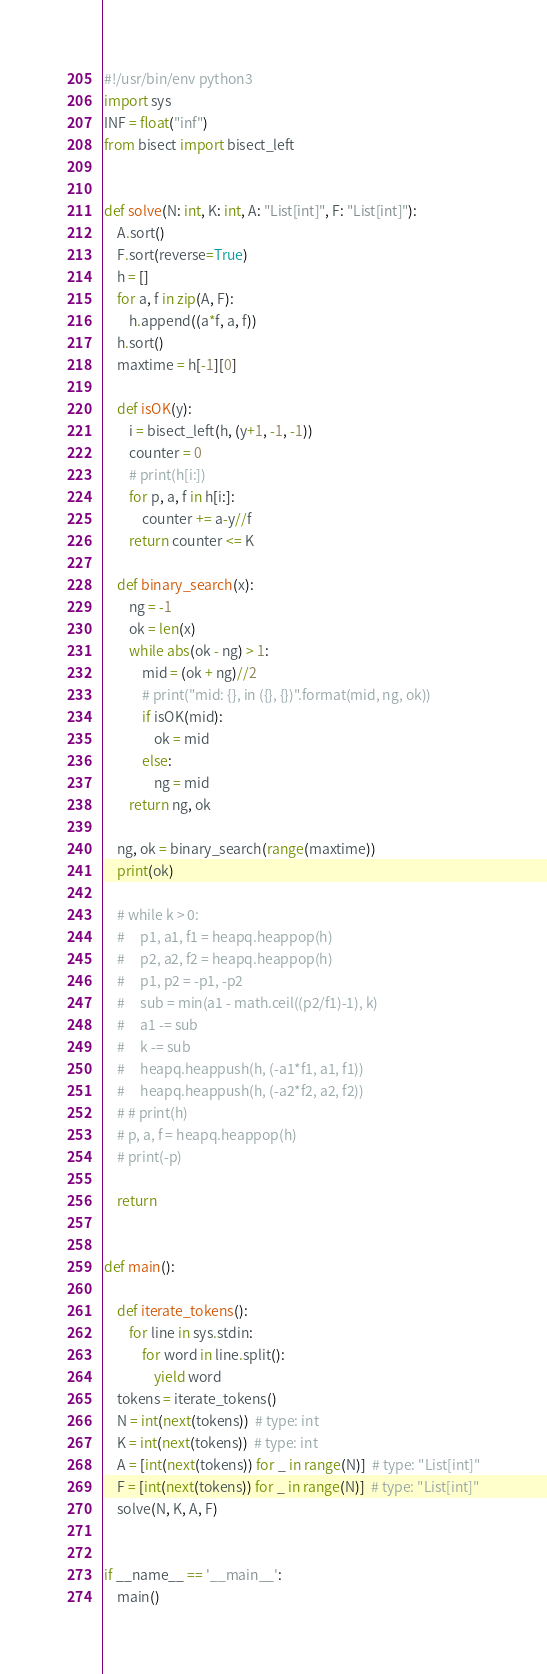<code> <loc_0><loc_0><loc_500><loc_500><_Python_>#!/usr/bin/env python3
import sys
INF = float("inf")
from bisect import bisect_left


def solve(N: int, K: int, A: "List[int]", F: "List[int]"):
    A.sort()
    F.sort(reverse=True)
    h = []
    for a, f in zip(A, F):
        h.append((a*f, a, f))
    h.sort()
    maxtime = h[-1][0]

    def isOK(y):
        i = bisect_left(h, (y+1, -1, -1))
        counter = 0
        # print(h[i:])
        for p, a, f in h[i:]:
            counter += a-y//f
        return counter <= K

    def binary_search(x):
        ng = -1
        ok = len(x)
        while abs(ok - ng) > 1:
            mid = (ok + ng)//2
            # print("mid: {}, in ({}, {})".format(mid, ng, ok))
            if isOK(mid):
                ok = mid
            else:
                ng = mid
        return ng, ok

    ng, ok = binary_search(range(maxtime))
    print(ok)

    # while k > 0:
    #     p1, a1, f1 = heapq.heappop(h)
    #     p2, a2, f2 = heapq.heappop(h)
    #     p1, p2 = -p1, -p2
    #     sub = min(a1 - math.ceil((p2/f1)-1), k)
    #     a1 -= sub
    #     k -= sub
    #     heapq.heappush(h, (-a1*f1, a1, f1))
    #     heapq.heappush(h, (-a2*f2, a2, f2))
    # # print(h)
    # p, a, f = heapq.heappop(h)
    # print(-p)

    return


def main():

    def iterate_tokens():
        for line in sys.stdin:
            for word in line.split():
                yield word
    tokens = iterate_tokens()
    N = int(next(tokens))  # type: int
    K = int(next(tokens))  # type: int
    A = [int(next(tokens)) for _ in range(N)]  # type: "List[int]"
    F = [int(next(tokens)) for _ in range(N)]  # type: "List[int]"
    solve(N, K, A, F)


if __name__ == '__main__':
    main()
</code> 